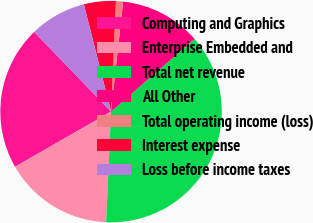Convert chart to OTSL. <chart><loc_0><loc_0><loc_500><loc_500><pie_chart><fcel>Computing and Graphics<fcel>Enterprise Embedded and<fcel>Total net revenue<fcel>All Other<fcel>Total operating income (loss)<fcel>Interest expense<fcel>Loss before income taxes<nl><fcel>21.1%<fcel>15.99%<fcel>37.1%<fcel>11.86%<fcel>1.04%<fcel>4.65%<fcel>8.25%<nl></chart> 